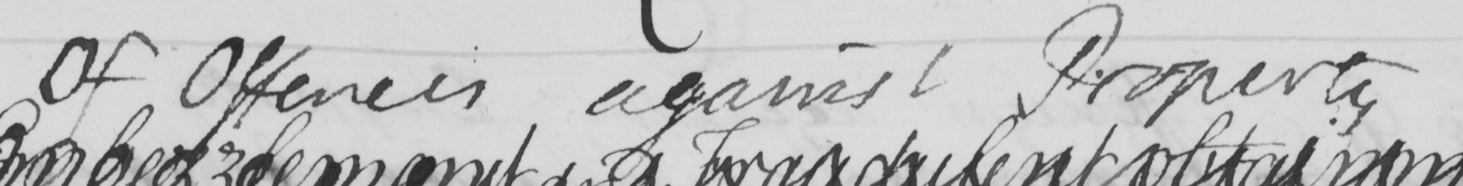Please provide the text content of this handwritten line. Of Offences against Property 